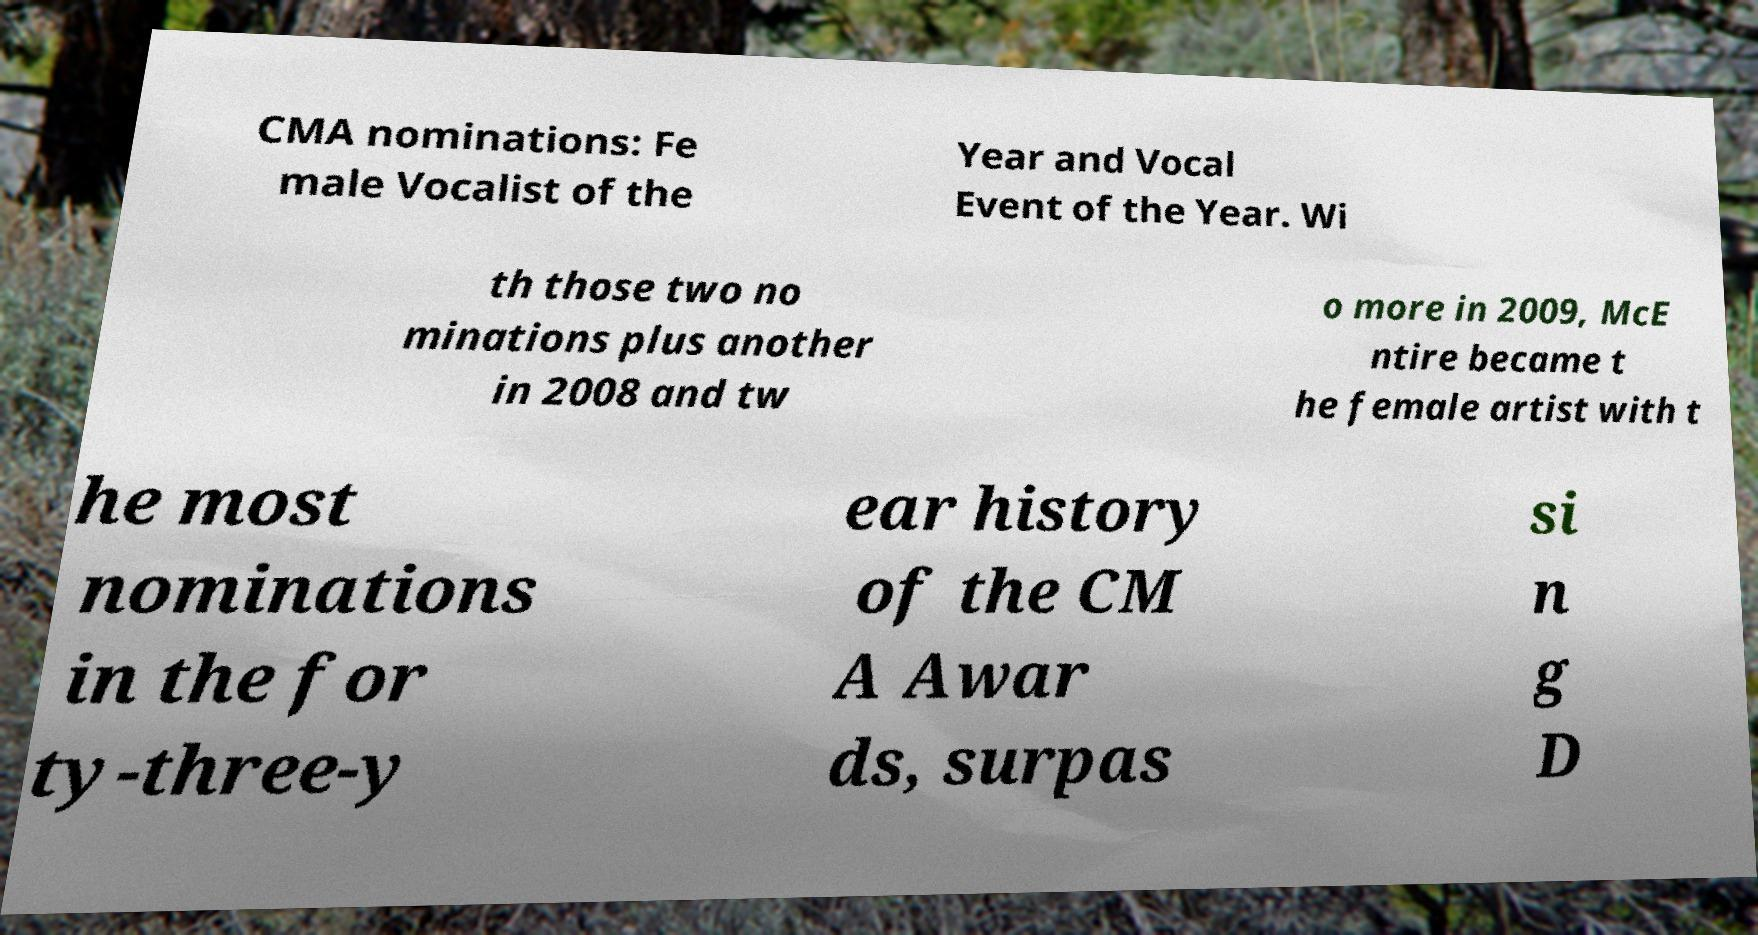What messages or text are displayed in this image? I need them in a readable, typed format. CMA nominations: Fe male Vocalist of the Year and Vocal Event of the Year. Wi th those two no minations plus another in 2008 and tw o more in 2009, McE ntire became t he female artist with t he most nominations in the for ty-three-y ear history of the CM A Awar ds, surpas si n g D 